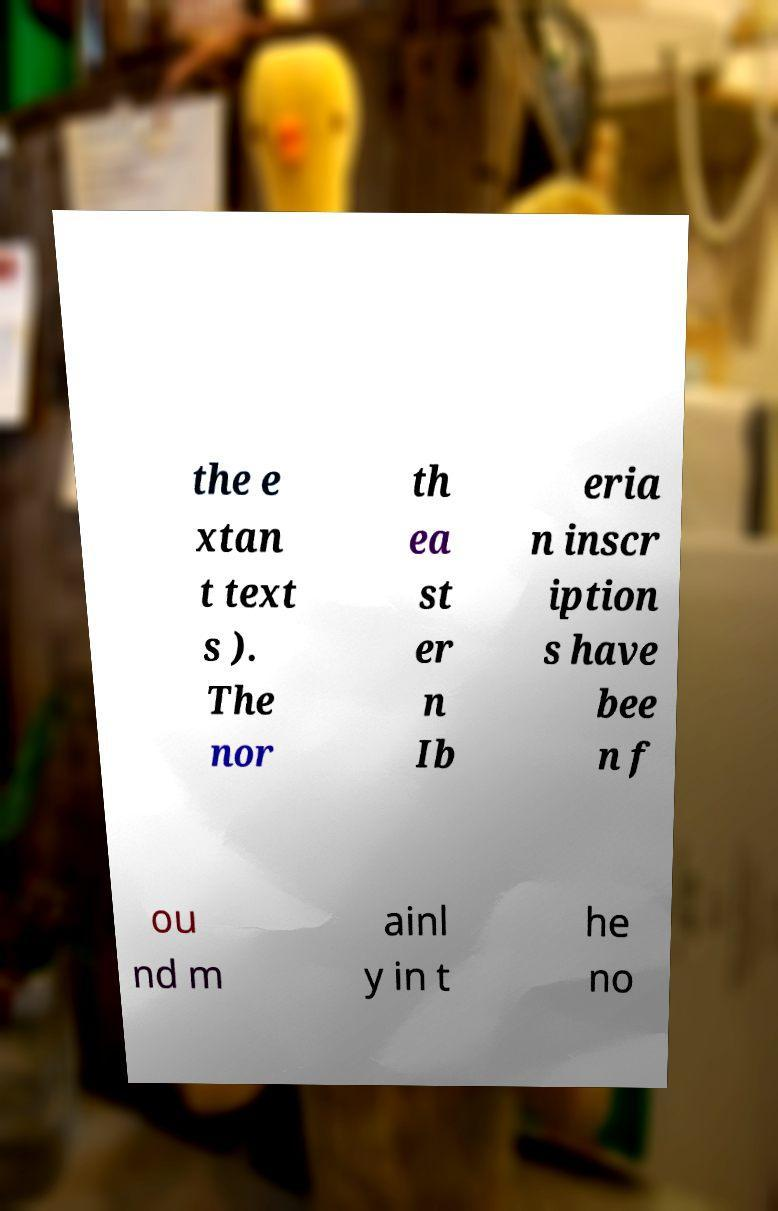Can you read and provide the text displayed in the image?This photo seems to have some interesting text. Can you extract and type it out for me? the e xtan t text s ). The nor th ea st er n Ib eria n inscr iption s have bee n f ou nd m ainl y in t he no 